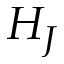<formula> <loc_0><loc_0><loc_500><loc_500>H _ { J }</formula> 